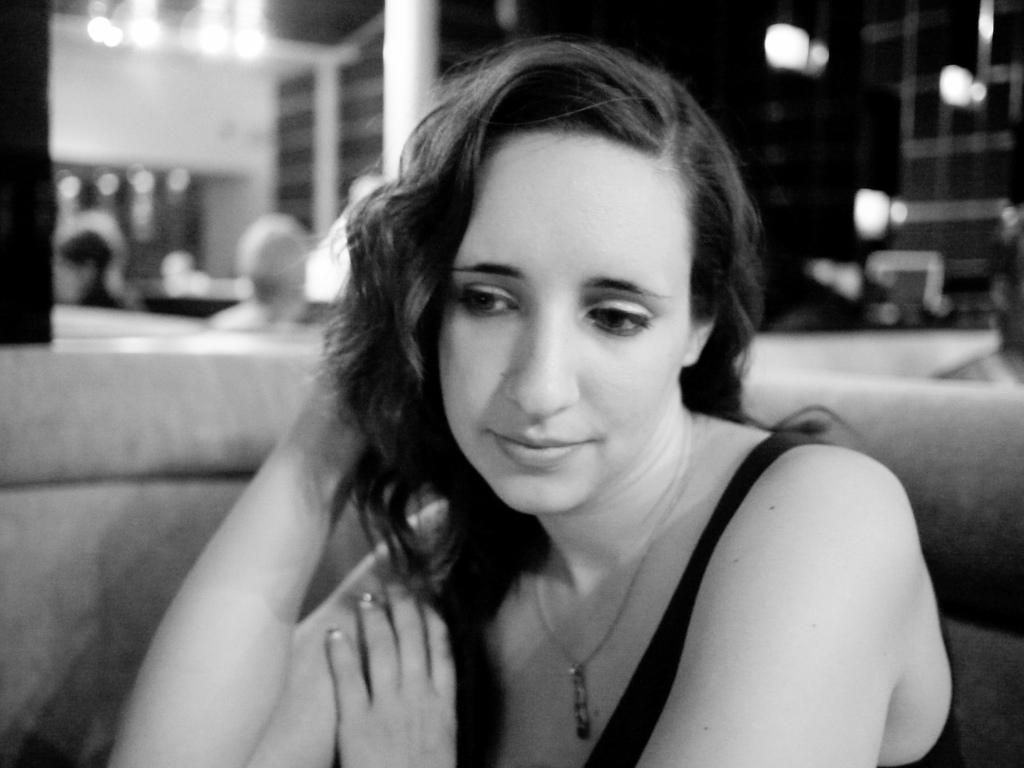In one or two sentences, can you explain what this image depicts? It is a black and white image. In this image in front there is a person sitting on the sofa. Behind her there are lights. On the backside there is a wall. 